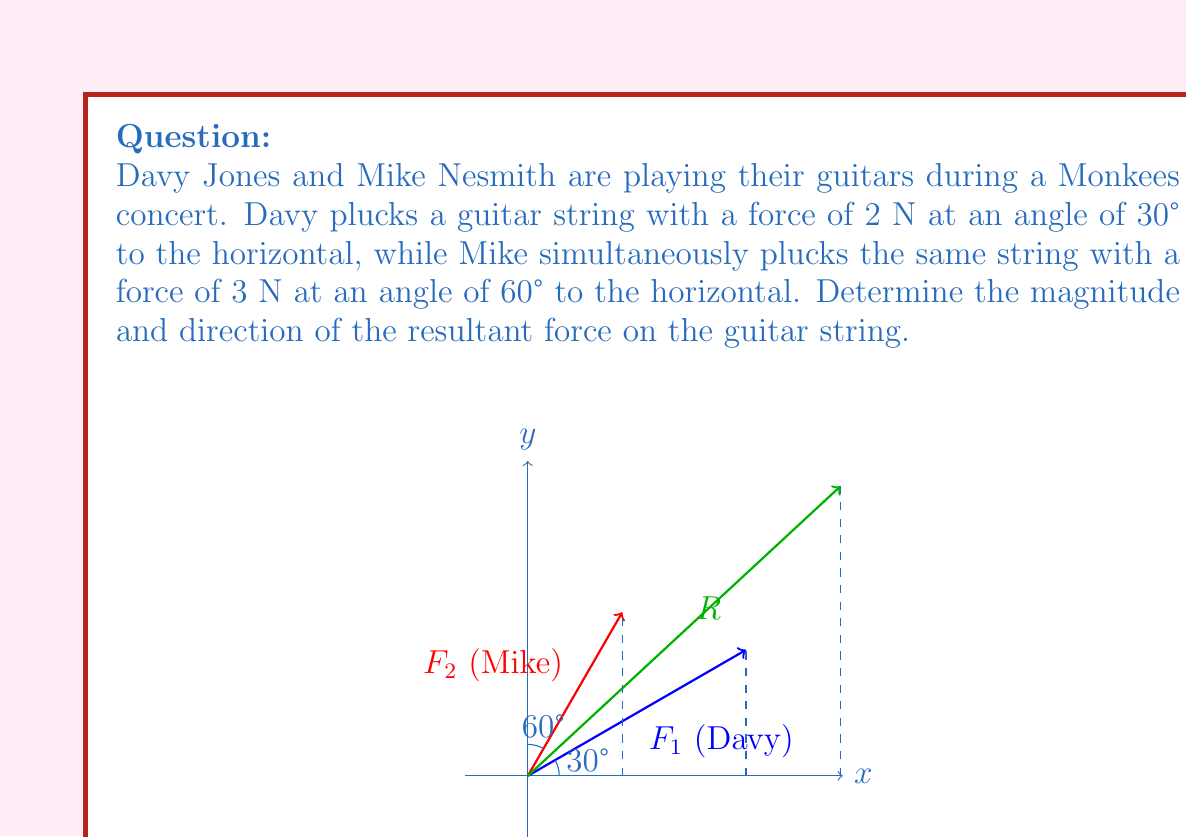Can you answer this question? Let's solve this step-by-step:

1) First, let's break down each force into its x and y components:

   For Davy's force ($F_1$):
   $F_{1x} = 2 \cos(30°) = 2 \cdot \frac{\sqrt{3}}{2} = \sqrt{3}$ N
   $F_{1y} = 2 \sin(30°) = 2 \cdot \frac{1}{2} = 1$ N

   For Mike's force ($F_2$):
   $F_{2x} = 3 \cos(60°) = 3 \cdot \frac{1}{2} = 1.5$ N
   $F_{2y} = 3 \sin(60°) = 3 \cdot \frac{\sqrt{3}}{2} = \frac{3\sqrt{3}}{2}$ N

2) Now, we sum the x and y components separately:

   $R_x = F_{1x} + F_{2x} = \sqrt{3} + 1.5 = \sqrt{3} + 1.5$ N
   $R_y = F_{1y} + F_{2y} = 1 + \frac{3\sqrt{3}}{2} = 1 + \frac{3\sqrt{3}}{2}$ N

3) To find the magnitude of the resultant force, we use the Pythagorean theorem:

   $R = \sqrt{R_x^2 + R_y^2} = \sqrt{(\sqrt{3} + 1.5)^2 + (1 + \frac{3\sqrt{3}}{2})^2}$

4) To find the direction, we use the arctangent function:

   $\theta = \tan^{-1}(\frac{R_y}{R_x}) = \tan^{-1}(\frac{1 + \frac{3\sqrt{3}}{2}}{\sqrt{3} + 1.5})$

5) Simplifying and calculating:

   $R \approx 4.964$ N
   $\theta \approx 42.8°$
Answer: $R \approx 4.964$ N, $\theta \approx 42.8°$ 